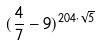Convert formula to latex. <formula><loc_0><loc_0><loc_500><loc_500>( \frac { 4 } { 7 } - 9 ) ^ { 2 0 4 \cdot \sqrt { 5 } }</formula> 